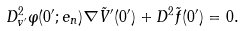<formula> <loc_0><loc_0><loc_500><loc_500>D ^ { 2 } _ { v ^ { \prime } } \varphi ( 0 ^ { \prime } ; e _ { n } ) \nabla \tilde { V } ^ { \prime } ( 0 ^ { \prime } ) + D ^ { 2 } \tilde { f } ( 0 ^ { \prime } ) = 0 .</formula> 